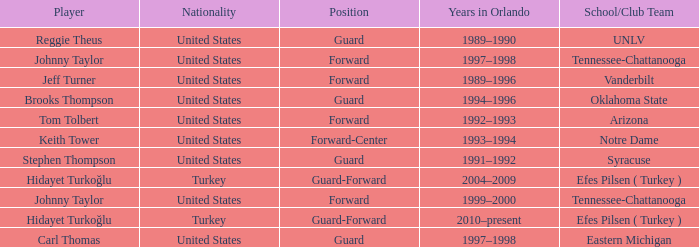What is Stephen Thompson's School/Club Team? Syracuse. 